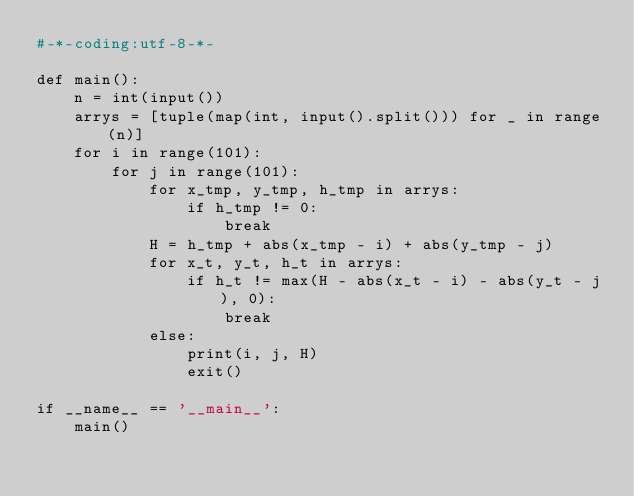Convert code to text. <code><loc_0><loc_0><loc_500><loc_500><_Python_>#-*-coding:utf-8-*-

def main():
    n = int(input())
    arrys = [tuple(map(int, input().split())) for _ in range(n)]
    for i in range(101):
        for j in range(101):
            for x_tmp, y_tmp, h_tmp in arrys:
                if h_tmp != 0:
                    break
            H = h_tmp + abs(x_tmp - i) + abs(y_tmp - j)
            for x_t, y_t, h_t in arrys:
                if h_t != max(H - abs(x_t - i) - abs(y_t - j), 0):
                    break
            else:
                print(i, j, H)
                exit()

if __name__ == '__main__':
    main()</code> 